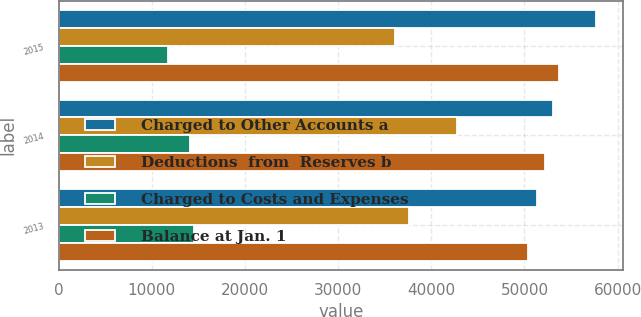<chart> <loc_0><loc_0><loc_500><loc_500><stacked_bar_chart><ecel><fcel>2015<fcel>2014<fcel>2013<nl><fcel>Charged to Other Accounts a<fcel>57719<fcel>53107<fcel>51394<nl><fcel>Deductions  from  Reserves b<fcel>36074<fcel>42765<fcel>37627<nl><fcel>Charged to Costs and Expenses<fcel>11784<fcel>14067<fcel>14469<nl><fcel>Balance at Jan. 1<fcel>53689<fcel>52220<fcel>50383<nl></chart> 